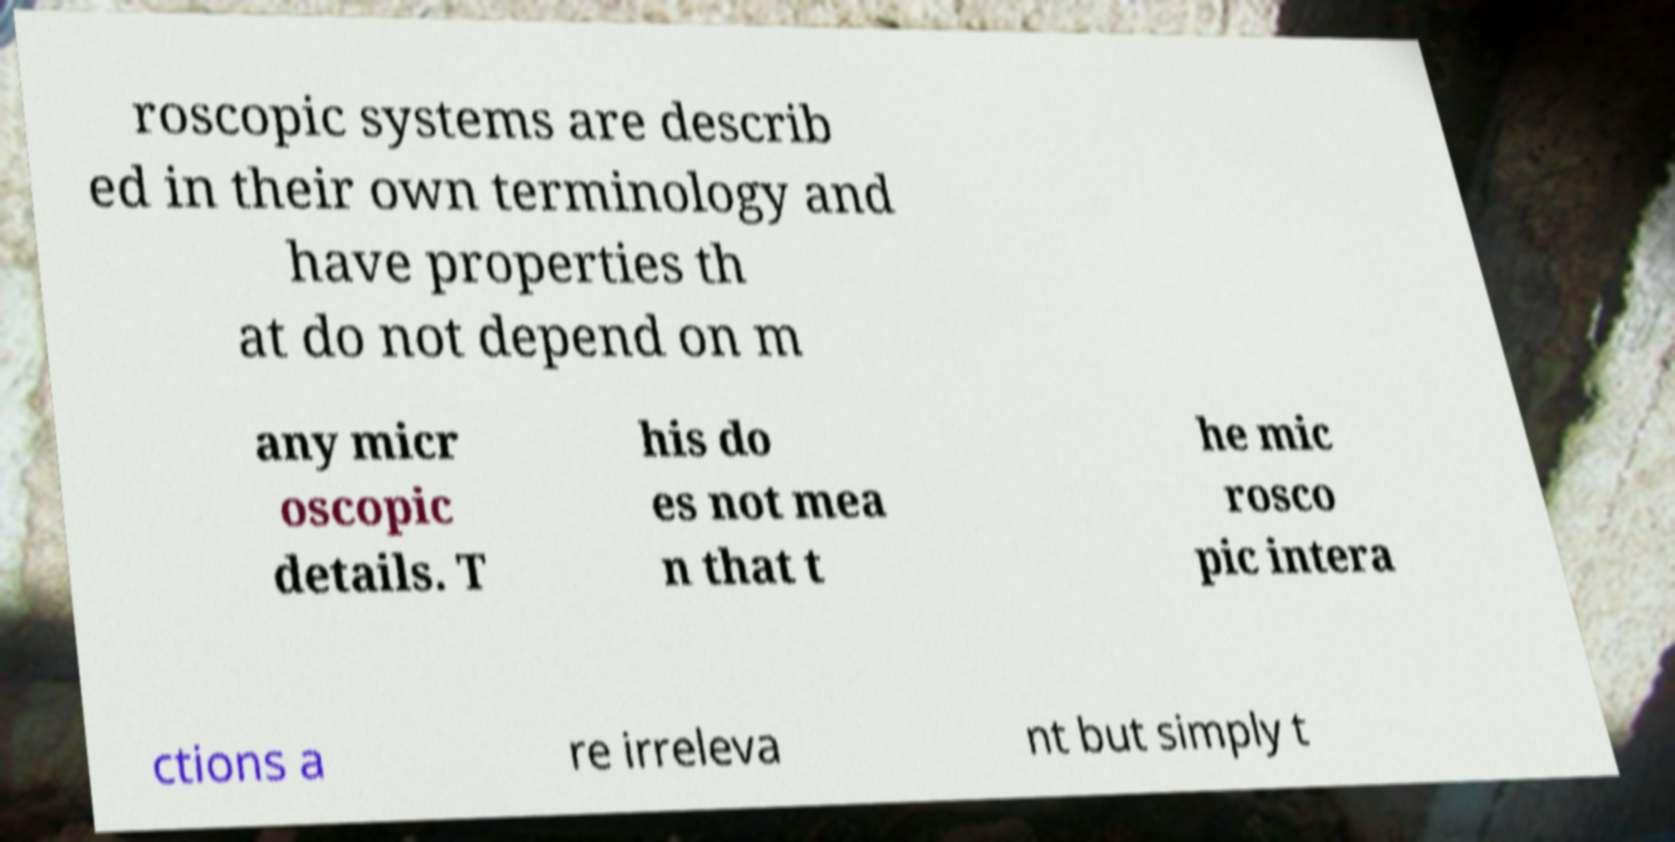Can you accurately transcribe the text from the provided image for me? roscopic systems are describ ed in their own terminology and have properties th at do not depend on m any micr oscopic details. T his do es not mea n that t he mic rosco pic intera ctions a re irreleva nt but simply t 